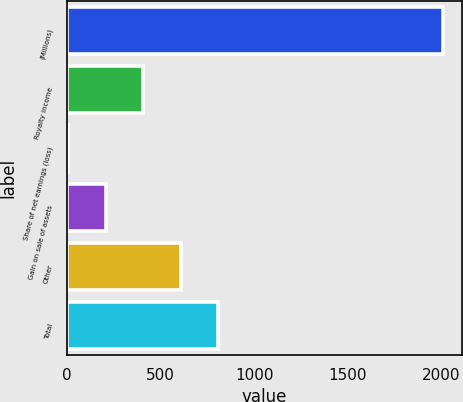Convert chart to OTSL. <chart><loc_0><loc_0><loc_500><loc_500><bar_chart><fcel>(Millions)<fcel>Royalty income<fcel>Share of net earnings (loss)<fcel>Gain on sale of assets<fcel>Other<fcel>Total<nl><fcel>2009<fcel>405.8<fcel>5<fcel>205.4<fcel>606.2<fcel>806.6<nl></chart> 